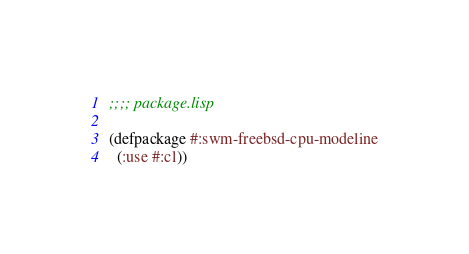Convert code to text. <code><loc_0><loc_0><loc_500><loc_500><_Lisp_>;;;; package.lisp

(defpackage #:swm-freebsd-cpu-modeline
  (:use #:cl))

</code> 